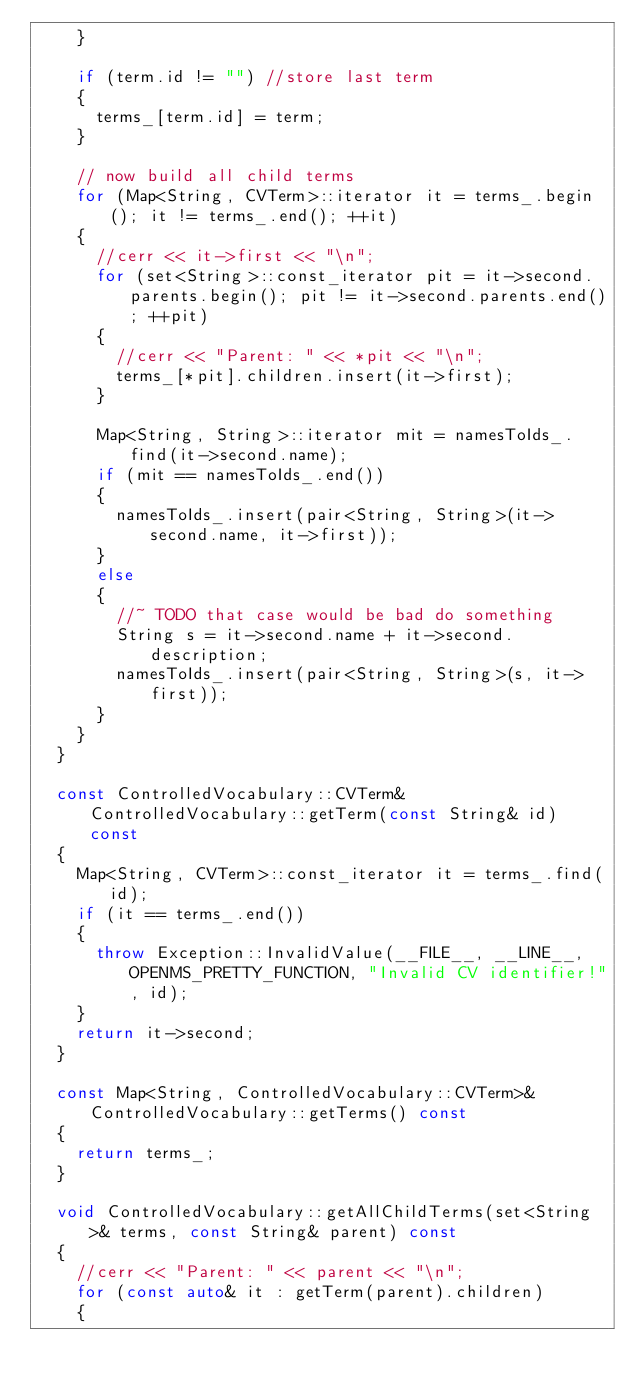Convert code to text. <code><loc_0><loc_0><loc_500><loc_500><_C++_>    }

    if (term.id != "") //store last term
    {
      terms_[term.id] = term;
    }

    // now build all child terms
    for (Map<String, CVTerm>::iterator it = terms_.begin(); it != terms_.end(); ++it)
    {
      //cerr << it->first << "\n";
      for (set<String>::const_iterator pit = it->second.parents.begin(); pit != it->second.parents.end(); ++pit)
      {
        //cerr << "Parent: " << *pit << "\n";
        terms_[*pit].children.insert(it->first);
      }

      Map<String, String>::iterator mit = namesToIds_.find(it->second.name);
      if (mit == namesToIds_.end())
      {
        namesToIds_.insert(pair<String, String>(it->second.name, it->first));
      }
      else
      {
        //~ TODO that case would be bad do something
        String s = it->second.name + it->second.description;
        namesToIds_.insert(pair<String, String>(s, it->first));
      }
    }
  }

  const ControlledVocabulary::CVTerm& ControlledVocabulary::getTerm(const String& id) const
  {
    Map<String, CVTerm>::const_iterator it = terms_.find(id);
    if (it == terms_.end())
    {
      throw Exception::InvalidValue(__FILE__, __LINE__, OPENMS_PRETTY_FUNCTION, "Invalid CV identifier!", id);
    }
    return it->second;
  }

  const Map<String, ControlledVocabulary::CVTerm>& ControlledVocabulary::getTerms() const
  {
    return terms_;
  }

  void ControlledVocabulary::getAllChildTerms(set<String>& terms, const String& parent) const
  {
    //cerr << "Parent: " << parent << "\n";
    for (const auto& it : getTerm(parent).children)
    {</code> 